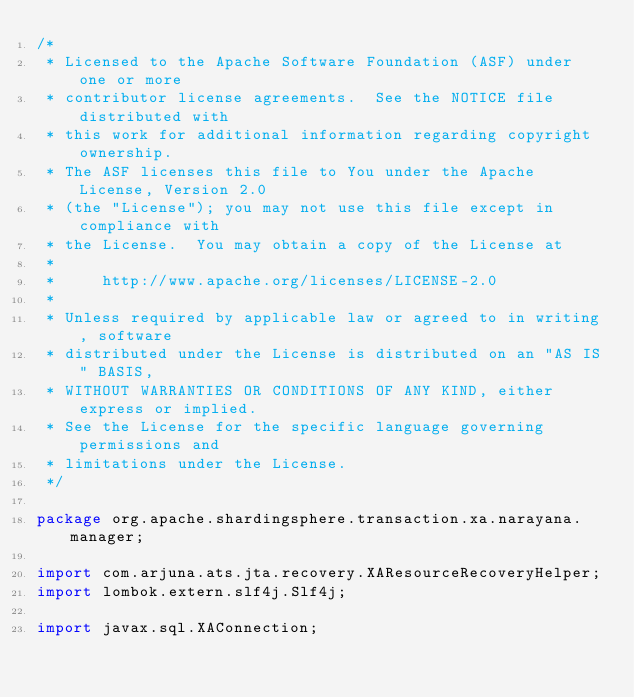Convert code to text. <code><loc_0><loc_0><loc_500><loc_500><_Java_>/*
 * Licensed to the Apache Software Foundation (ASF) under one or more
 * contributor license agreements.  See the NOTICE file distributed with
 * this work for additional information regarding copyright ownership.
 * The ASF licenses this file to You under the Apache License, Version 2.0
 * (the "License"); you may not use this file except in compliance with
 * the License.  You may obtain a copy of the License at
 *
 *     http://www.apache.org/licenses/LICENSE-2.0
 *
 * Unless required by applicable law or agreed to in writing, software
 * distributed under the License is distributed on an "AS IS" BASIS,
 * WITHOUT WARRANTIES OR CONDITIONS OF ANY KIND, either express or implied.
 * See the License for the specific language governing permissions and
 * limitations under the License.
 */

package org.apache.shardingsphere.transaction.xa.narayana.manager;

import com.arjuna.ats.jta.recovery.XAResourceRecoveryHelper;
import lombok.extern.slf4j.Slf4j;

import javax.sql.XAConnection;</code> 